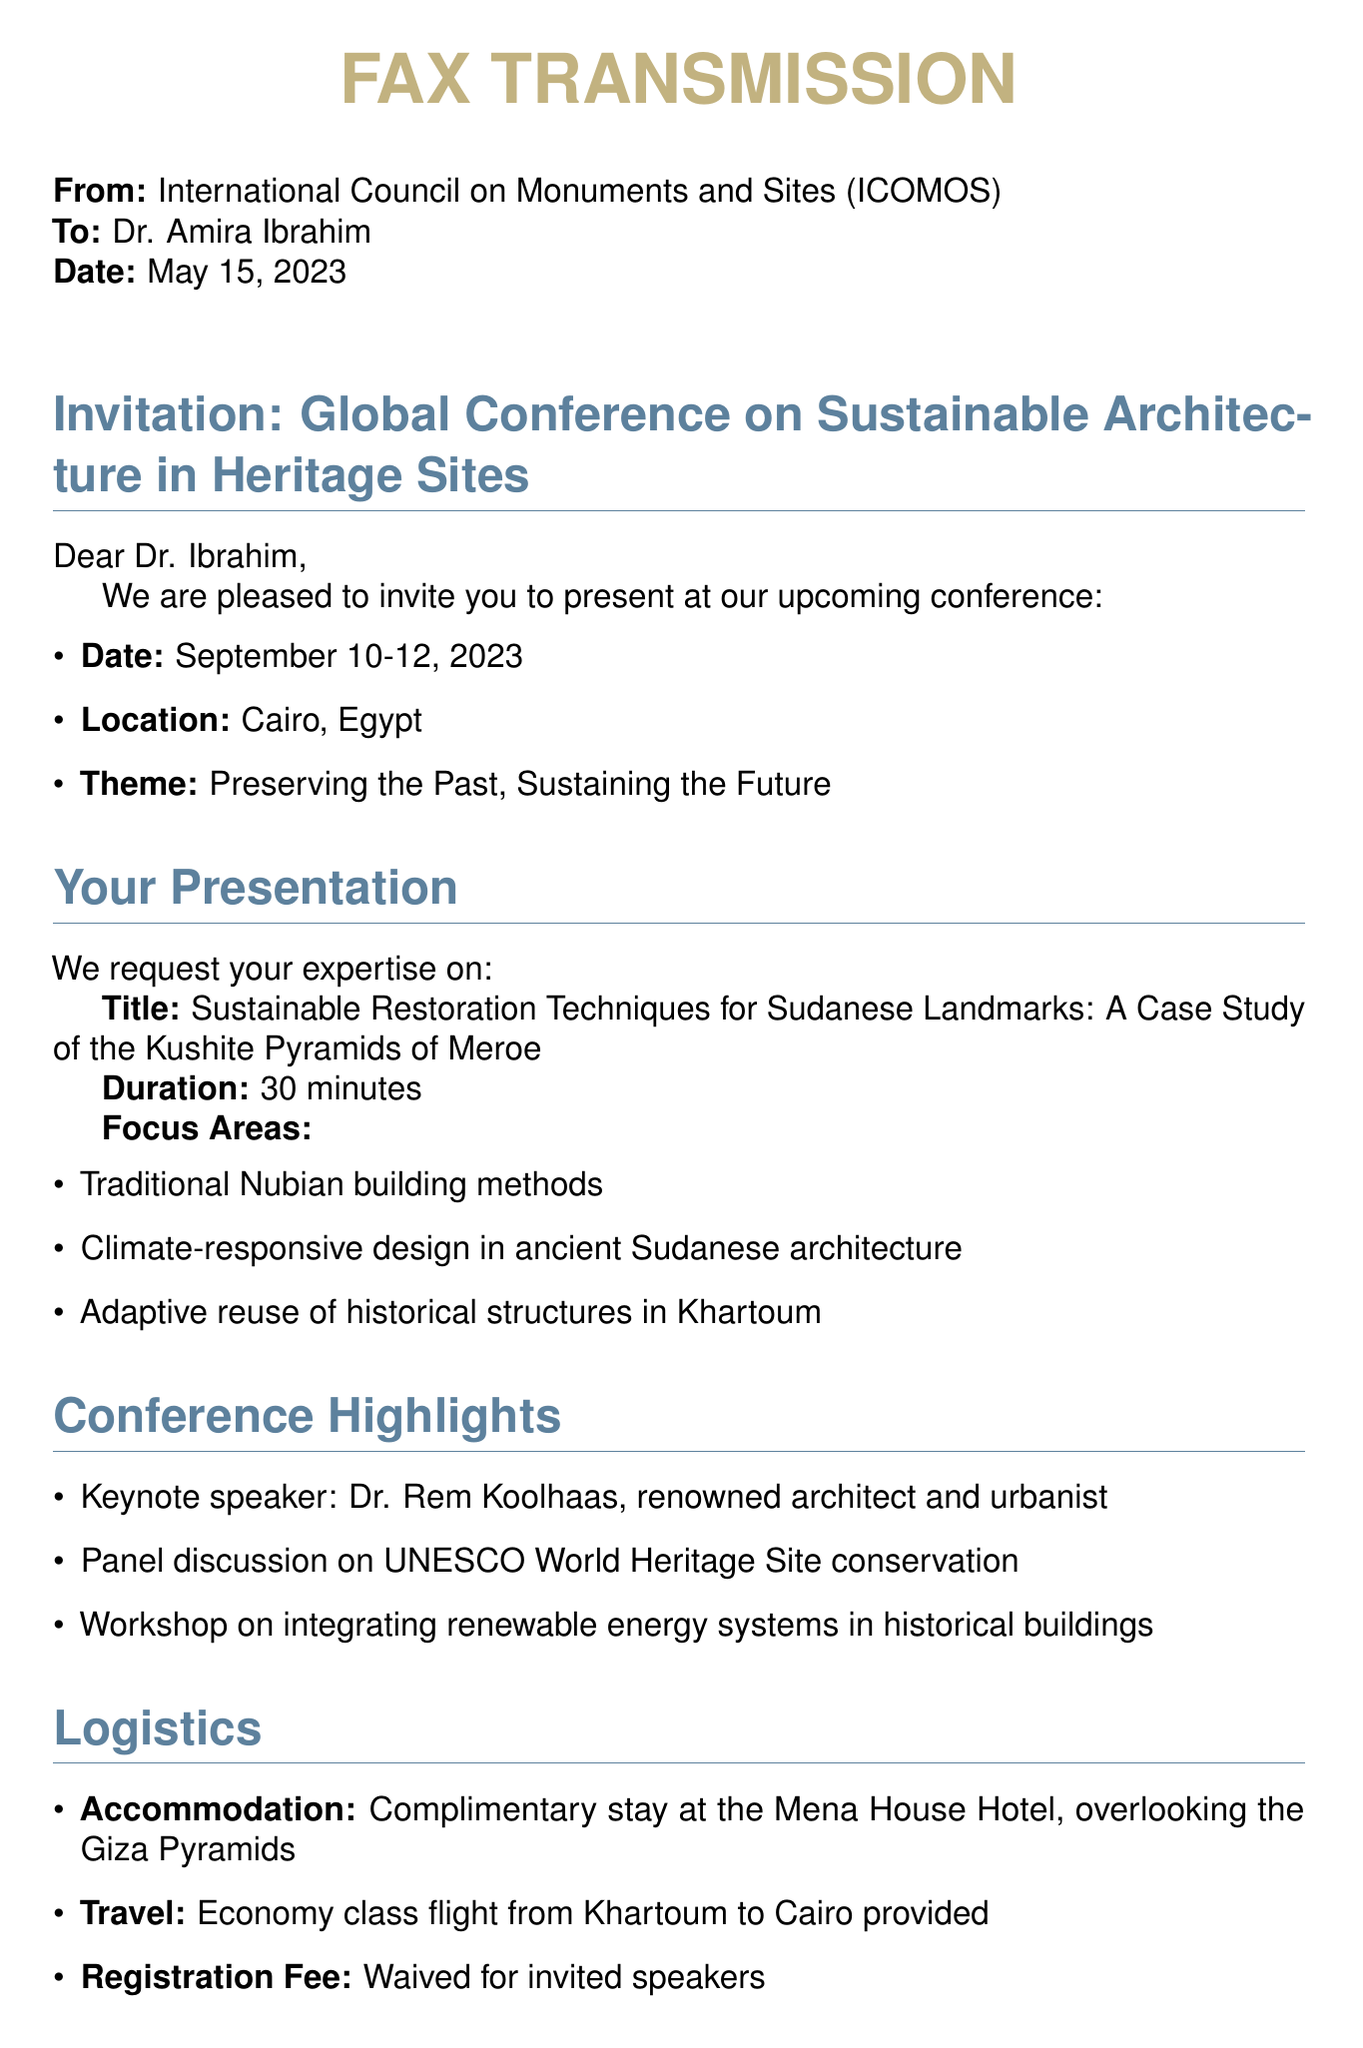What is the sender's organization? The sender's organization is specified at the top of the document as the International Council on Monuments and Sites (ICOMOS).
Answer: ICOMOS Who is the recipient of the fax? The recipient's name is mentioned directly after the sender's organization in the document.
Answer: Dr. Amira Ibrahim What are the dates of the conference? The dates of the conference are noted in the invitation section of the document.
Answer: September 10-12, 2023 What is the title of the presentation requested? The title of the requested presentation is provided under the presentation section of the document.
Answer: Sustainable Restoration Techniques for Sudanese Landmarks: A Case Study of the Kushite Pyramids of Meroe Who is the keynote speaker at the conference? The name of the keynote speaker is listed in the conference highlights section of the document.
Answer: Dr. Rem Koolhaas What is the location of the conference? The location of the conference is stated in the invitation section near the dates.
Answer: Cairo, Egypt What is the registration fee for invited speakers? The registration fee for invited speakers is clearly stated in the logistics section of the document.
Answer: Waived When is the response deadline? The deadline for responses is listed in the response instructions section of the document.
Answer: June 15, 2023 What type of hotel accommodation is provided? The type of hotel accommodation is specified in the logistics section of the document.
Answer: Complimentary stay at the Mena House Hotel 